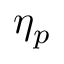<formula> <loc_0><loc_0><loc_500><loc_500>\eta _ { p }</formula> 